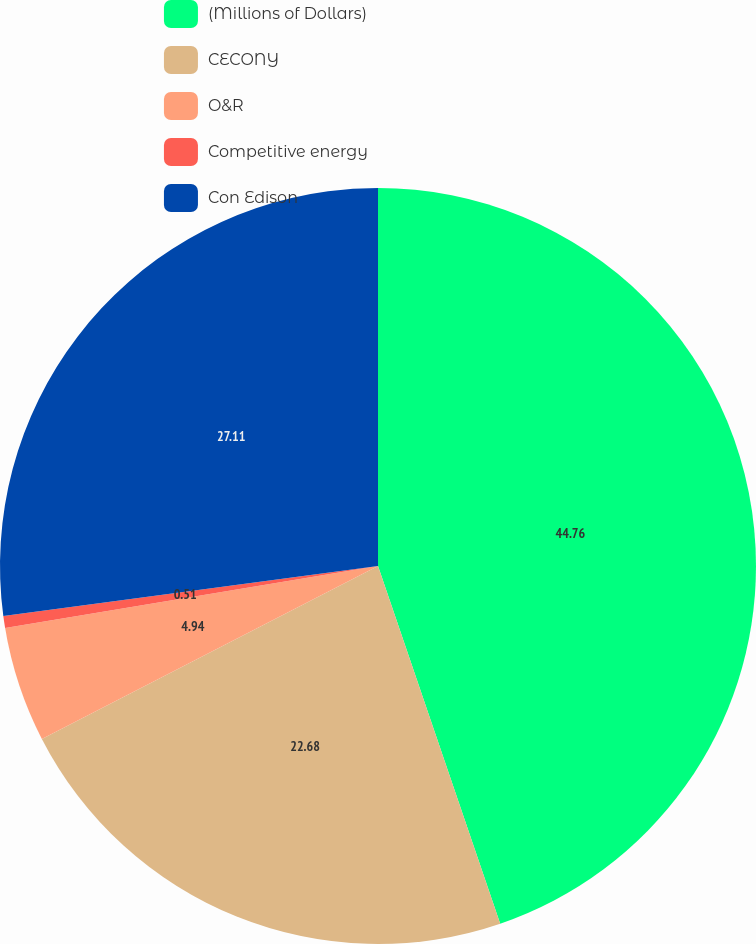Convert chart. <chart><loc_0><loc_0><loc_500><loc_500><pie_chart><fcel>(Millions of Dollars)<fcel>CECONY<fcel>O&R<fcel>Competitive energy<fcel>Con Edison<nl><fcel>44.76%<fcel>22.68%<fcel>4.94%<fcel>0.51%<fcel>27.11%<nl></chart> 